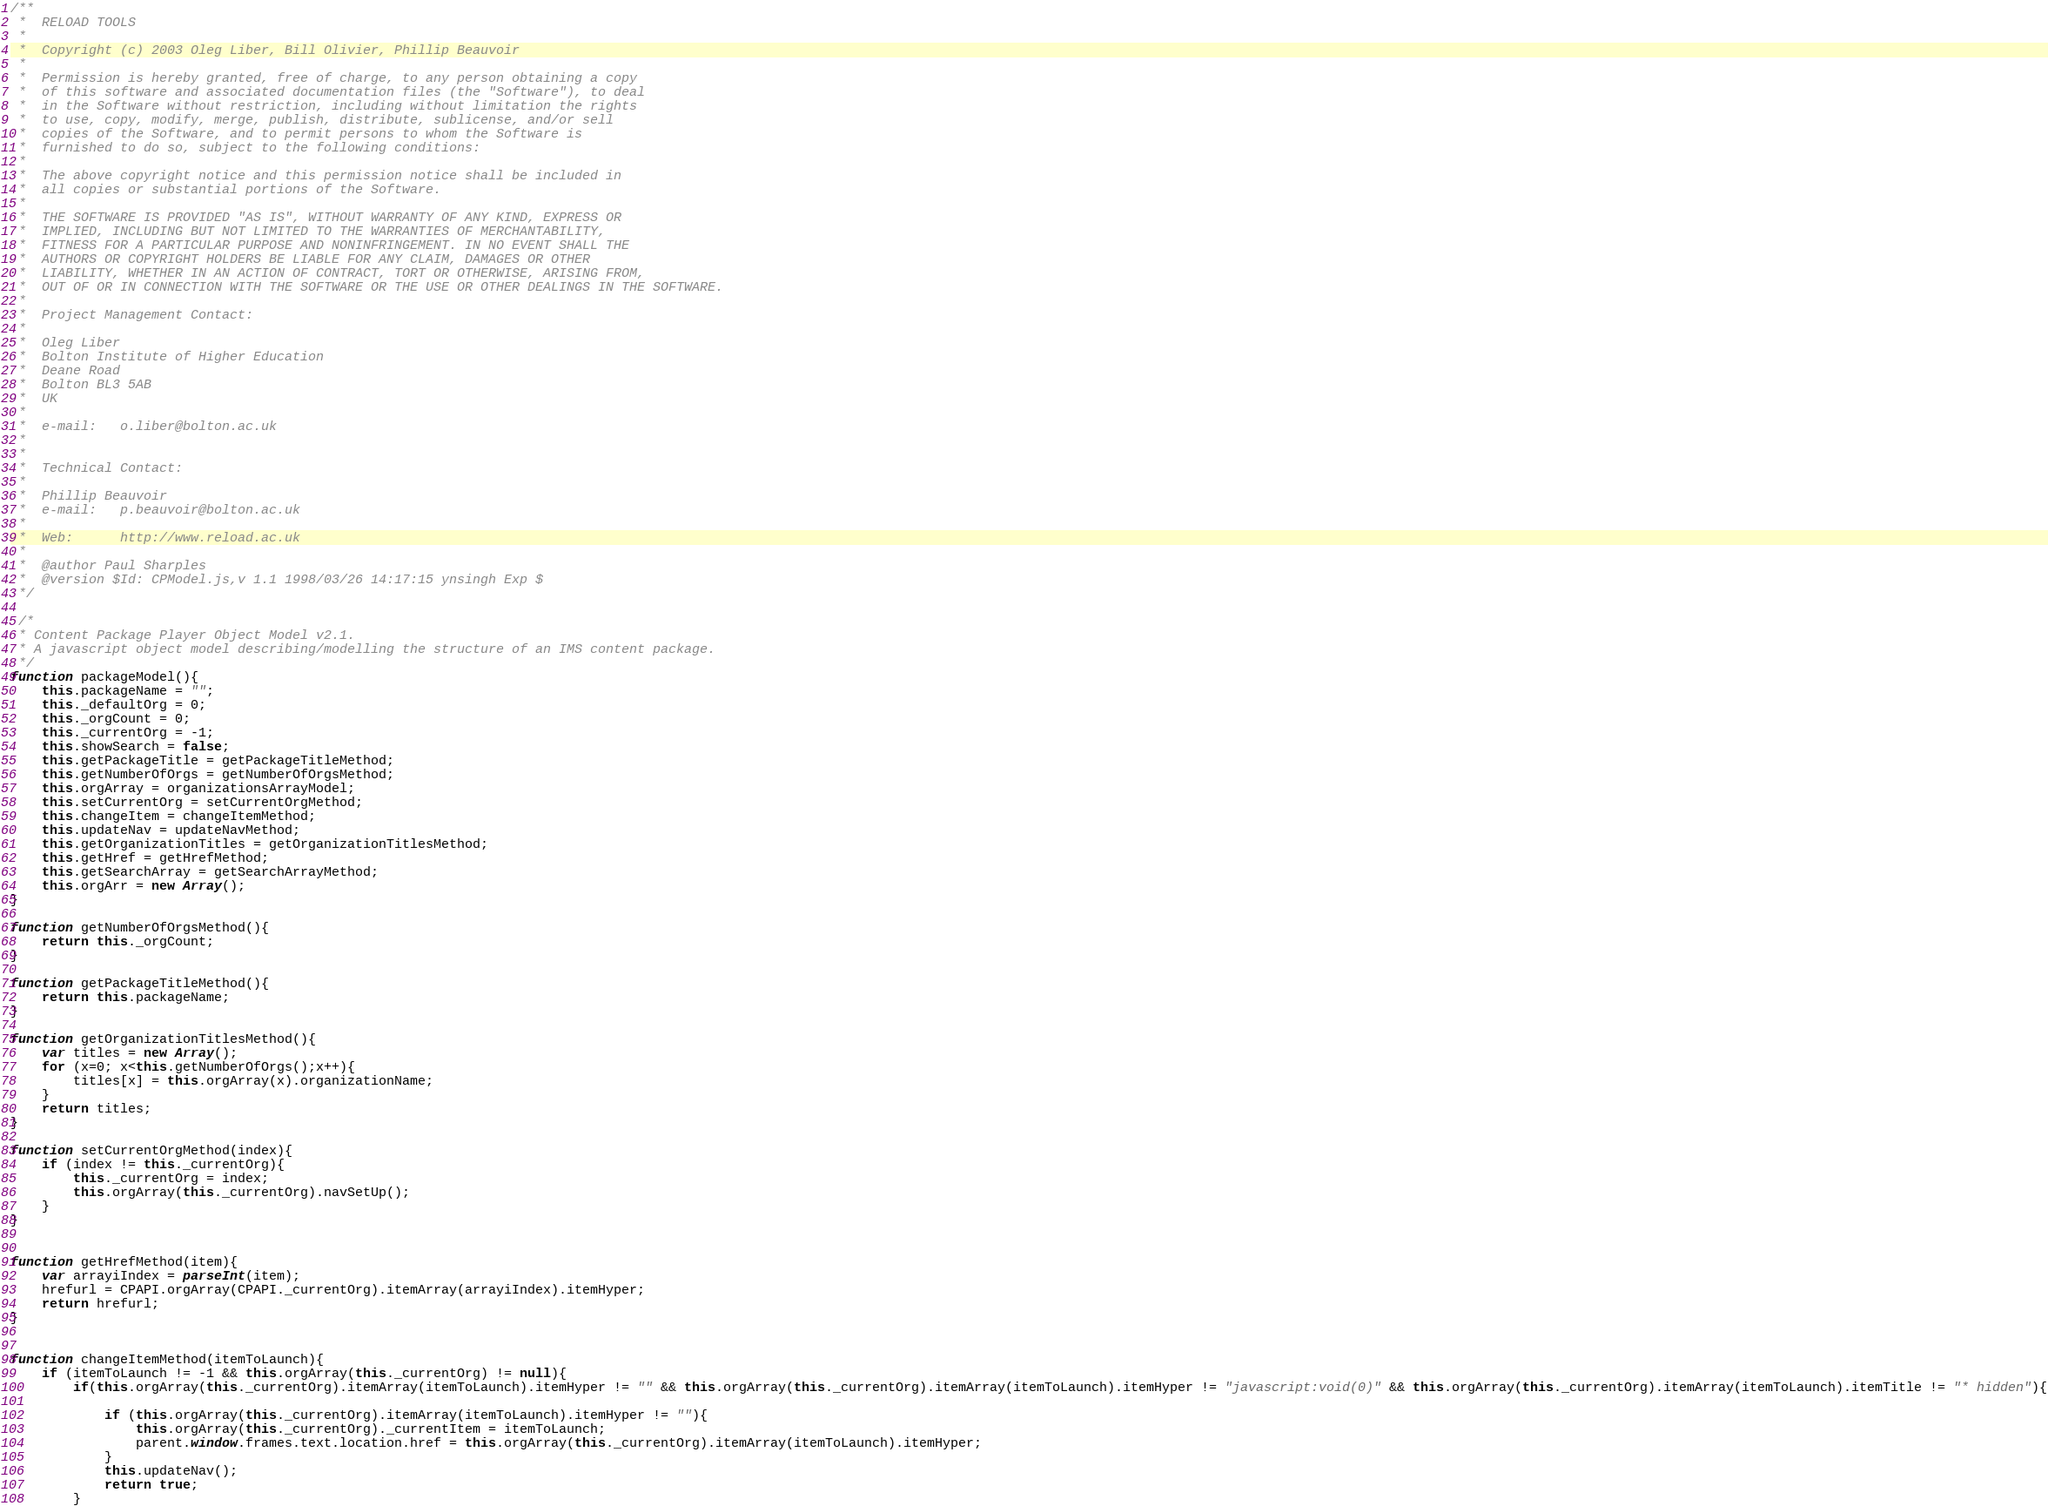<code> <loc_0><loc_0><loc_500><loc_500><_JavaScript_>/**
 *  RELOAD TOOLS
 *
 *  Copyright (c) 2003 Oleg Liber, Bill Olivier, Phillip Beauvoir
 *
 *  Permission is hereby granted, free of charge, to any person obtaining a copy
 *  of this software and associated documentation files (the "Software"), to deal
 *  in the Software without restriction, including without limitation the rights
 *  to use, copy, modify, merge, publish, distribute, sublicense, and/or sell
 *  copies of the Software, and to permit persons to whom the Software is
 *  furnished to do so, subject to the following conditions:
 *
 *  The above copyright notice and this permission notice shall be included in
 *  all copies or substantial portions of the Software.
 *
 *  THE SOFTWARE IS PROVIDED "AS IS", WITHOUT WARRANTY OF ANY KIND, EXPRESS OR
 *  IMPLIED, INCLUDING BUT NOT LIMITED TO THE WARRANTIES OF MERCHANTABILITY,
 *  FITNESS FOR A PARTICULAR PURPOSE AND NONINFRINGEMENT. IN NO EVENT SHALL THE
 *  AUTHORS OR COPYRIGHT HOLDERS BE LIABLE FOR ANY CLAIM, DAMAGES OR OTHER
 *  LIABILITY, WHETHER IN AN ACTION OF CONTRACT, TORT OR OTHERWISE, ARISING FROM,
 *  OUT OF OR IN CONNECTION WITH THE SOFTWARE OR THE USE OR OTHER DEALINGS IN THE SOFTWARE.
 *
 *  Project Management Contact:
 *
 *  Oleg Liber
 *  Bolton Institute of Higher Education
 *  Deane Road
 *  Bolton BL3 5AB
 *  UK
 *
 *  e-mail:   o.liber@bolton.ac.uk
 *
 *
 *  Technical Contact:
 *
 *  Phillip Beauvoir
 *  e-mail:   p.beauvoir@bolton.ac.uk
 *
 *  Web:      http://www.reload.ac.uk
 *
 *  @author Paul Sharples
 *  @version $Id: CPModel.js,v 1.1 1998/03/26 14:17:15 ynsingh Exp $
 */

 /*
 * Content Package Player Object Model v2.1.
 * A javascript object model describing/modelling the structure of an IMS content package.
 */ 
function packageModel(){
	this.packageName = "";
	this._defaultOrg = 0;
	this._orgCount = 0;
	this._currentOrg = -1;
	this.showSearch = false;
	this.getPackageTitle = getPackageTitleMethod;	
	this.getNumberOfOrgs = getNumberOfOrgsMethod;
	this.orgArray = organizationsArrayModel;
	this.setCurrentOrg = setCurrentOrgMethod;
	this.changeItem = changeItemMethod;
	this.updateNav = updateNavMethod;
	this.getOrganizationTitles = getOrganizationTitlesMethod;
	this.getHref = getHrefMethod;
	this.getSearchArray = getSearchArrayMethod;
	this.orgArr = new Array();	
}

function getNumberOfOrgsMethod(){
	return this._orgCount;
}

function getPackageTitleMethod(){
	return this.packageName;	
}

function getOrganizationTitlesMethod(){
	var titles = new Array();
	for (x=0; x<this.getNumberOfOrgs();x++){
		titles[x] = this.orgArray(x).organizationName;
	}
	return titles;
}

function setCurrentOrgMethod(index){
	if (index != this._currentOrg){
		this._currentOrg = index;
		this.orgArray(this._currentOrg).navSetUp();
	}
}


function getHrefMethod(item){
	var arrayiIndex = parseInt(item);	
	hrefurl = CPAPI.orgArray(CPAPI._currentOrg).itemArray(arrayiIndex).itemHyper;		
	return hrefurl; 	
}


function changeItemMethod(itemToLaunch){
	if (itemToLaunch != -1 && this.orgArray(this._currentOrg) != null){
		if(this.orgArray(this._currentOrg).itemArray(itemToLaunch).itemHyper != "" && this.orgArray(this._currentOrg).itemArray(itemToLaunch).itemHyper != "javascript:void(0)" && this.orgArray(this._currentOrg).itemArray(itemToLaunch).itemTitle != "* hidden"){
			
			if (this.orgArray(this._currentOrg).itemArray(itemToLaunch).itemHyper != ""){
				this.orgArray(this._currentOrg)._currentItem = itemToLaunch;
				parent.window.frames.text.location.href = this.orgArray(this._currentOrg).itemArray(itemToLaunch).itemHyper;		
			}
			this.updateNav();
			return true;
		}</code> 